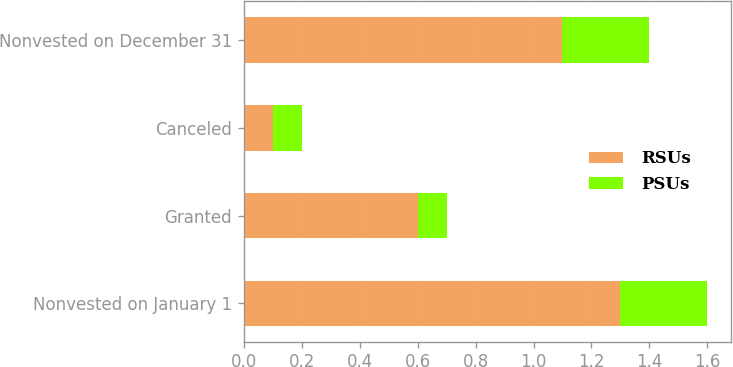<chart> <loc_0><loc_0><loc_500><loc_500><stacked_bar_chart><ecel><fcel>Nonvested on January 1<fcel>Granted<fcel>Canceled<fcel>Nonvested on December 31<nl><fcel>RSUs<fcel>1.3<fcel>0.6<fcel>0.1<fcel>1.1<nl><fcel>PSUs<fcel>0.3<fcel>0.1<fcel>0.1<fcel>0.3<nl></chart> 